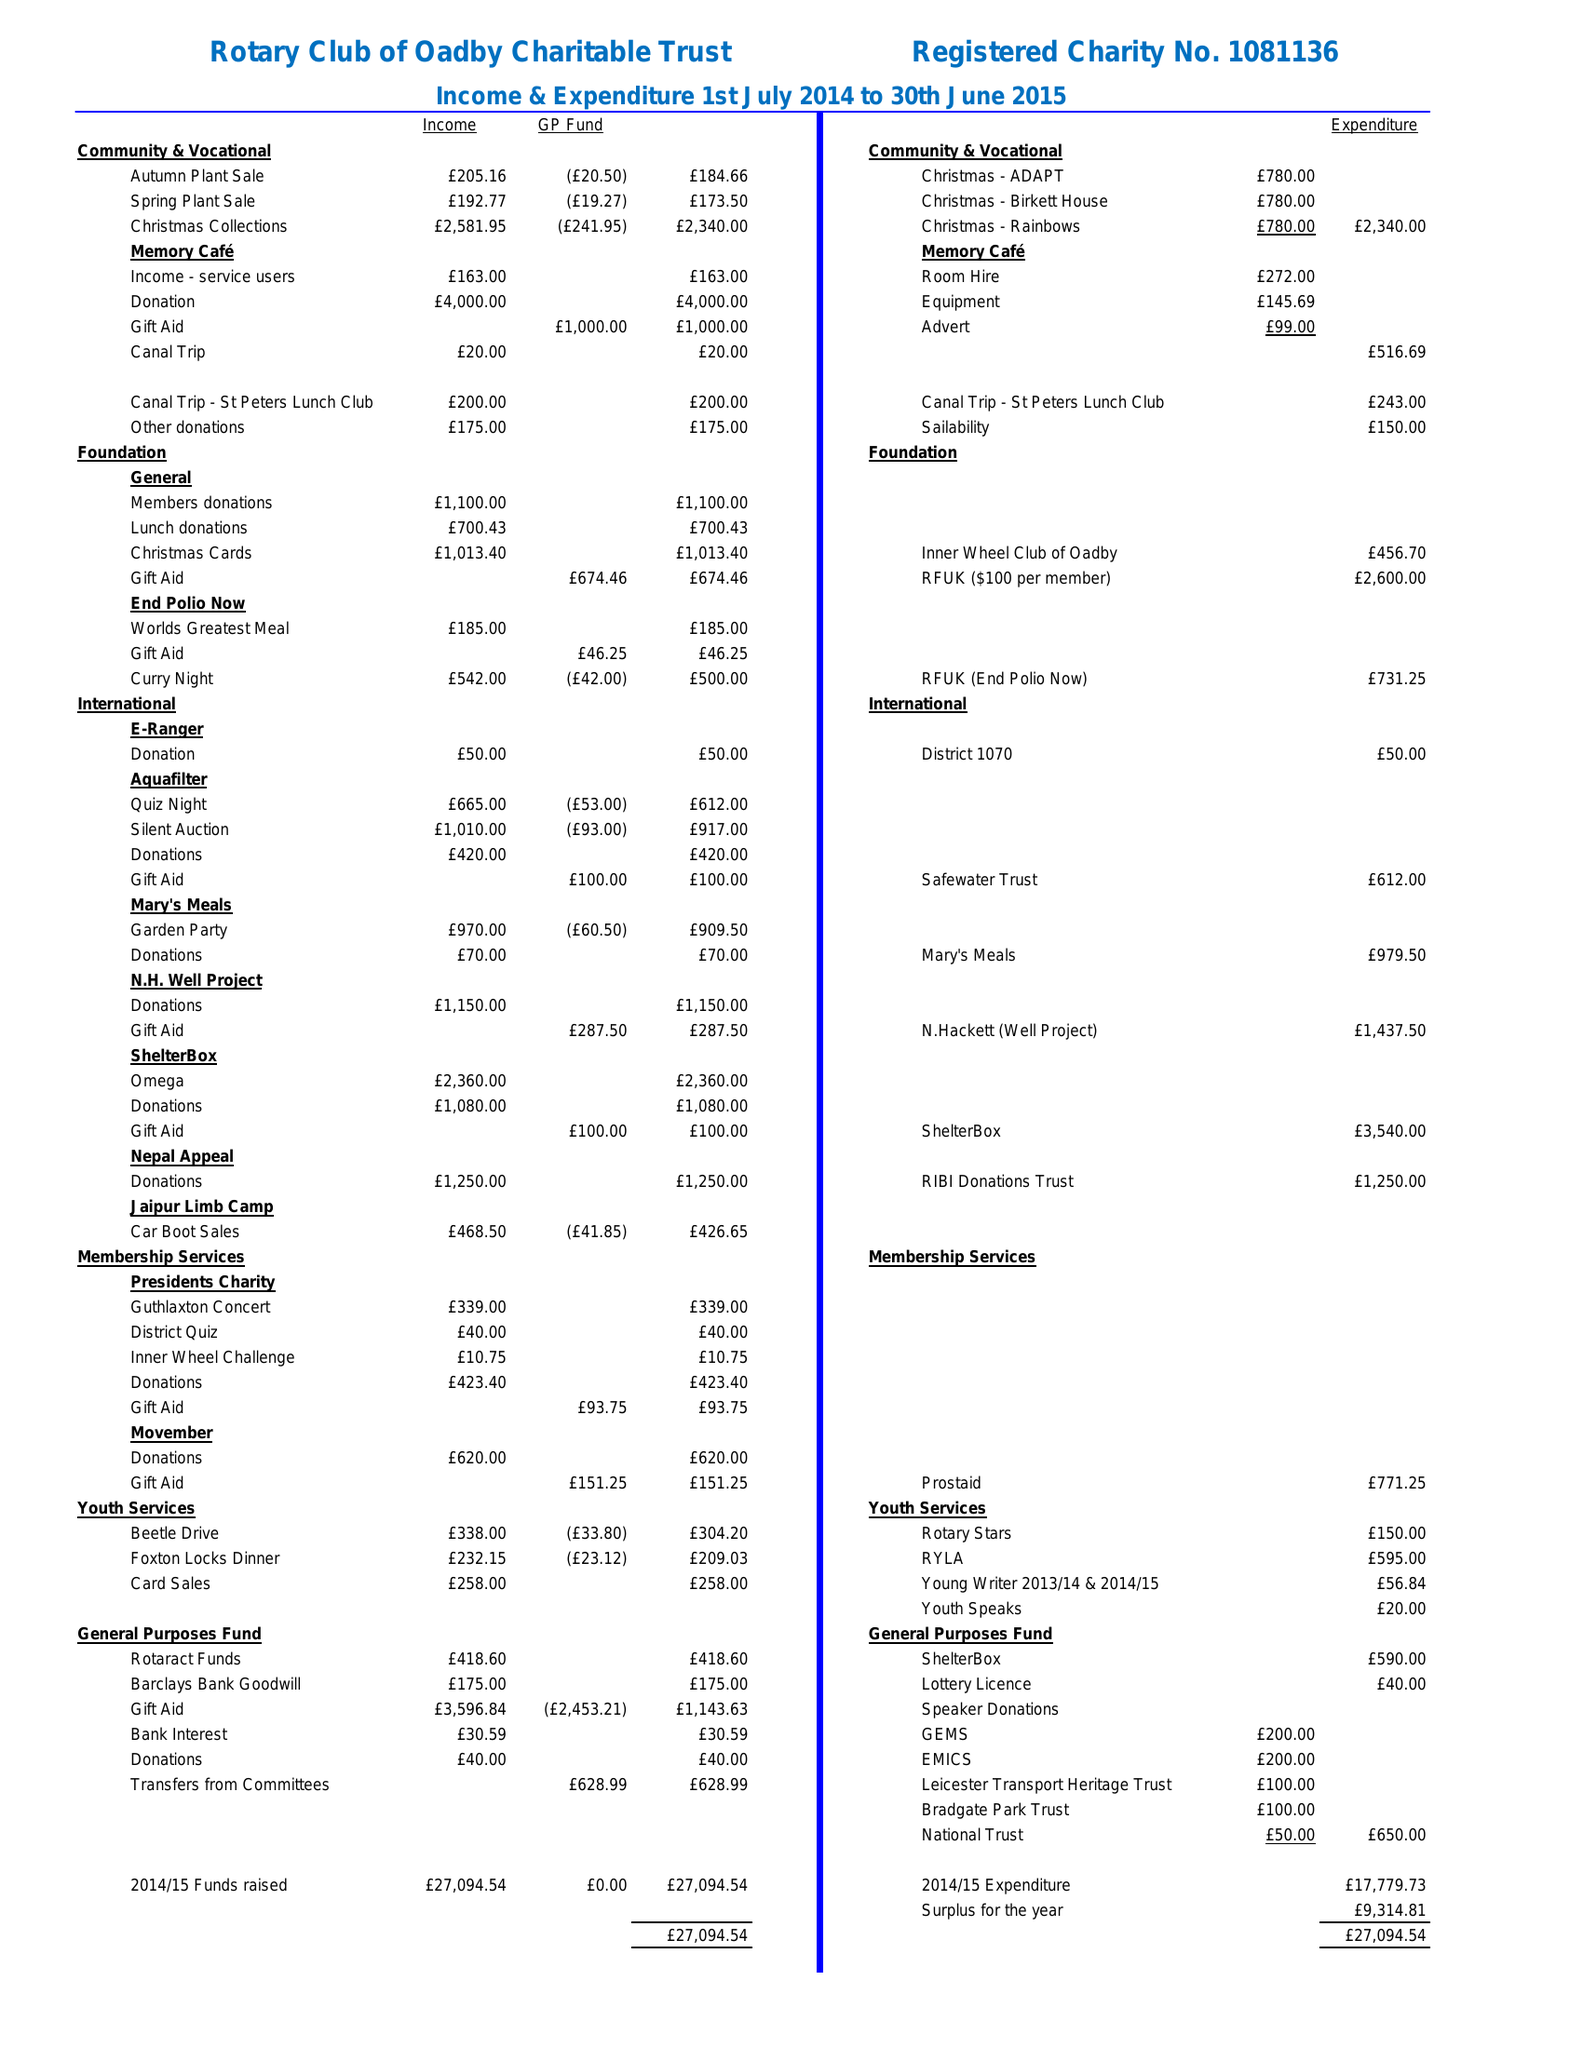What is the value for the report_date?
Answer the question using a single word or phrase. 2015-06-30 